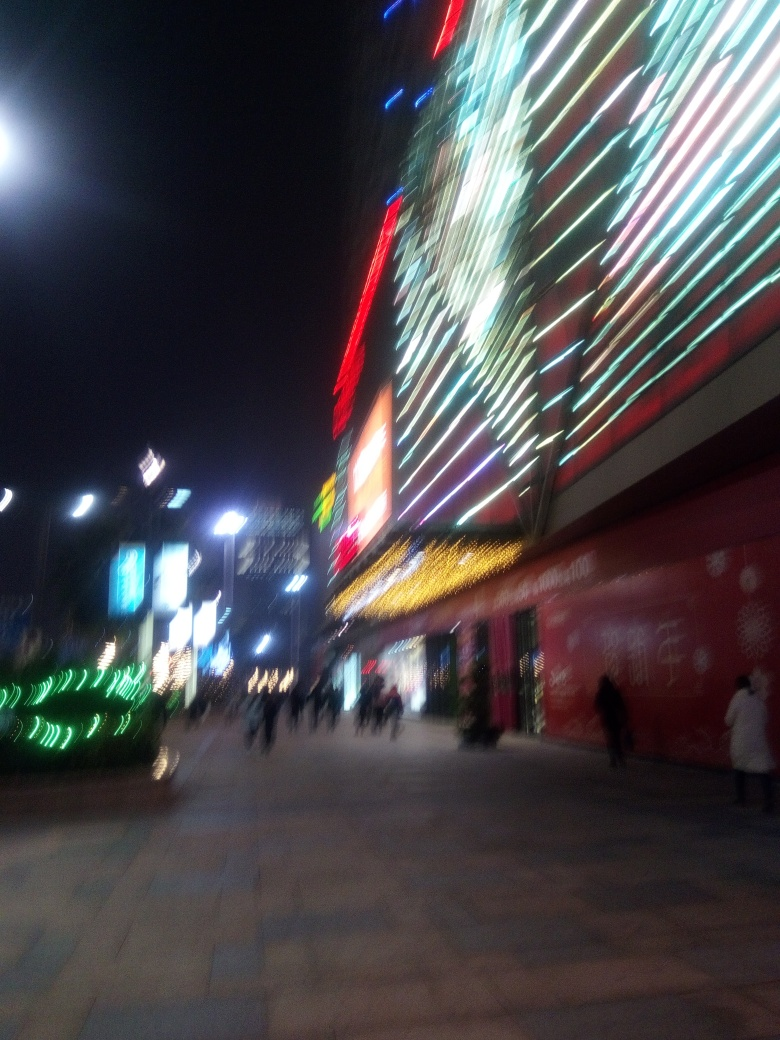Why is the portrayal of the subject unclear?
A. severe motion blur
B. perfect lighting
C. excessive sharpness
D. vivid colors
Answer with the option's letter from the given choices directly.
 A. 